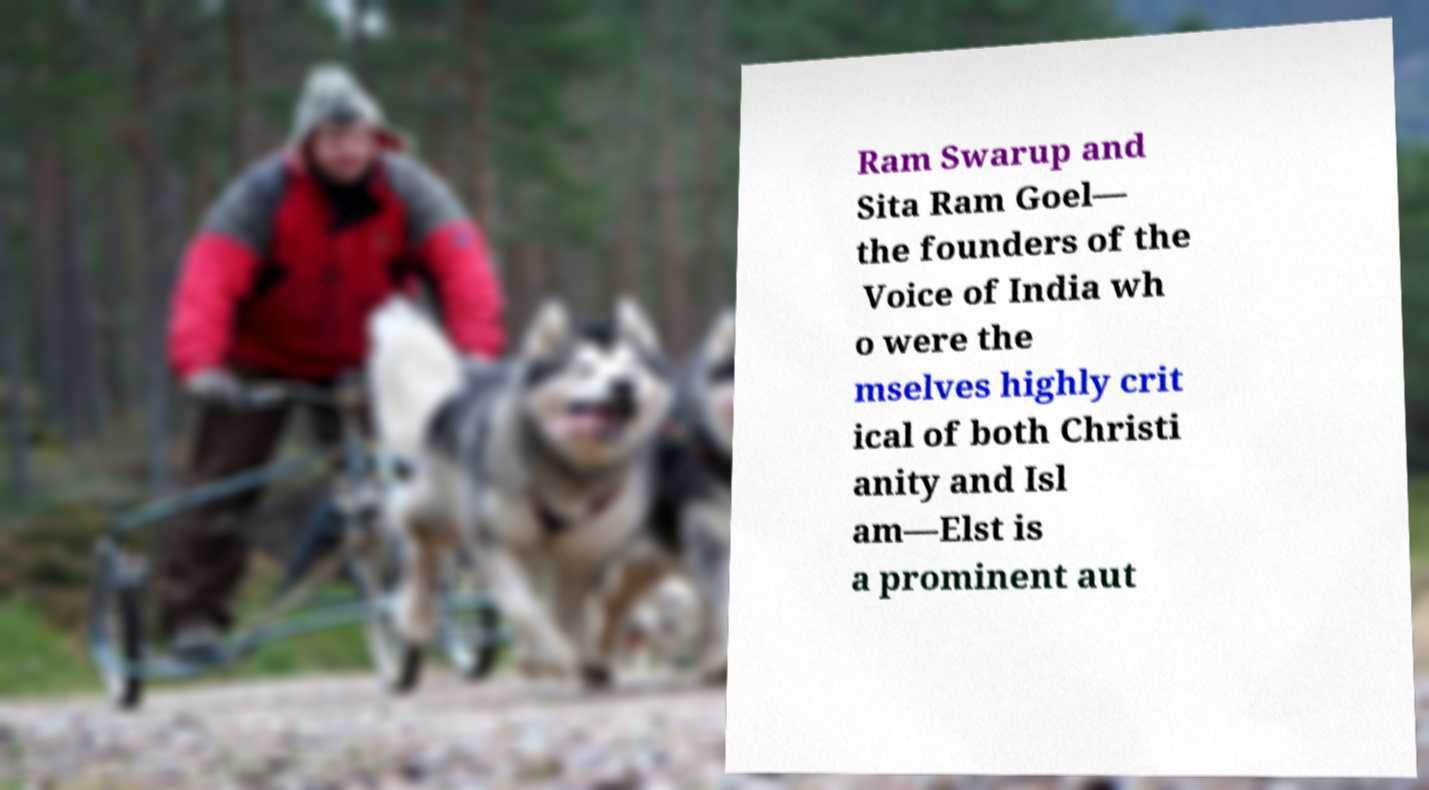Please identify and transcribe the text found in this image. Ram Swarup and Sita Ram Goel— the founders of the Voice of India wh o were the mselves highly crit ical of both Christi anity and Isl am—Elst is a prominent aut 